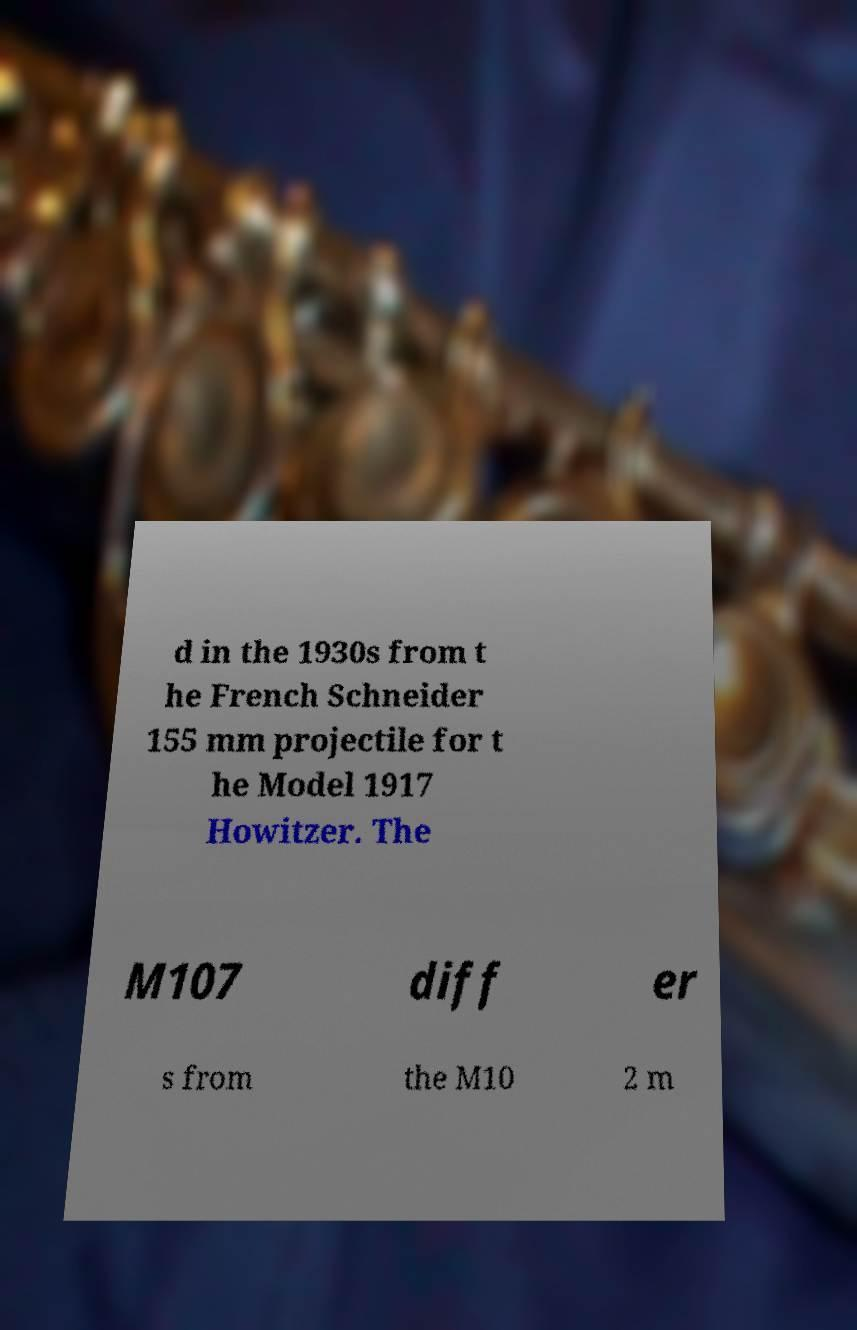Can you read and provide the text displayed in the image?This photo seems to have some interesting text. Can you extract and type it out for me? d in the 1930s from t he French Schneider 155 mm projectile for t he Model 1917 Howitzer. The M107 diff er s from the M10 2 m 